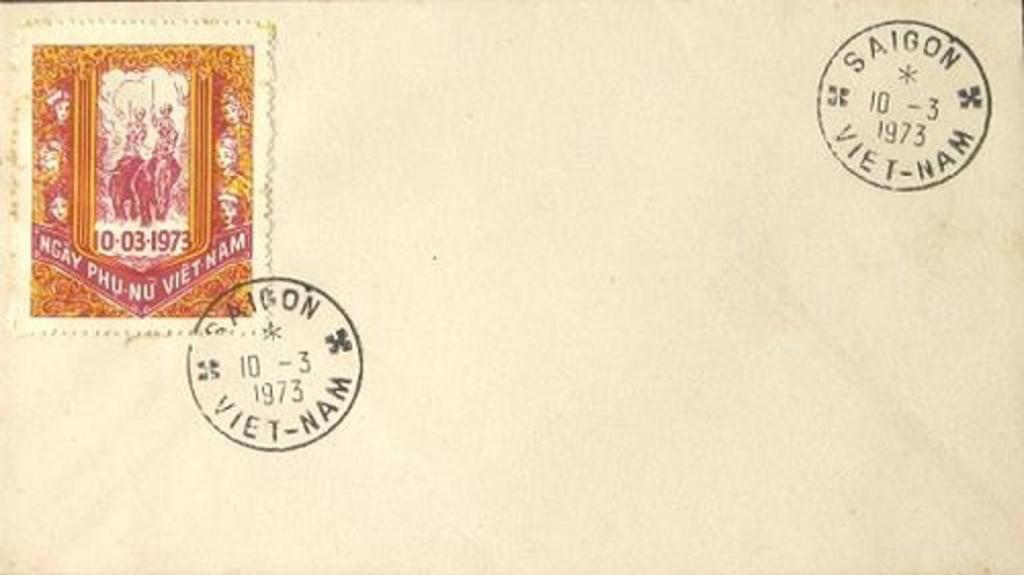<image>
Describe the image concisely. The letter was mailed through the Saigon post office in 1973. 